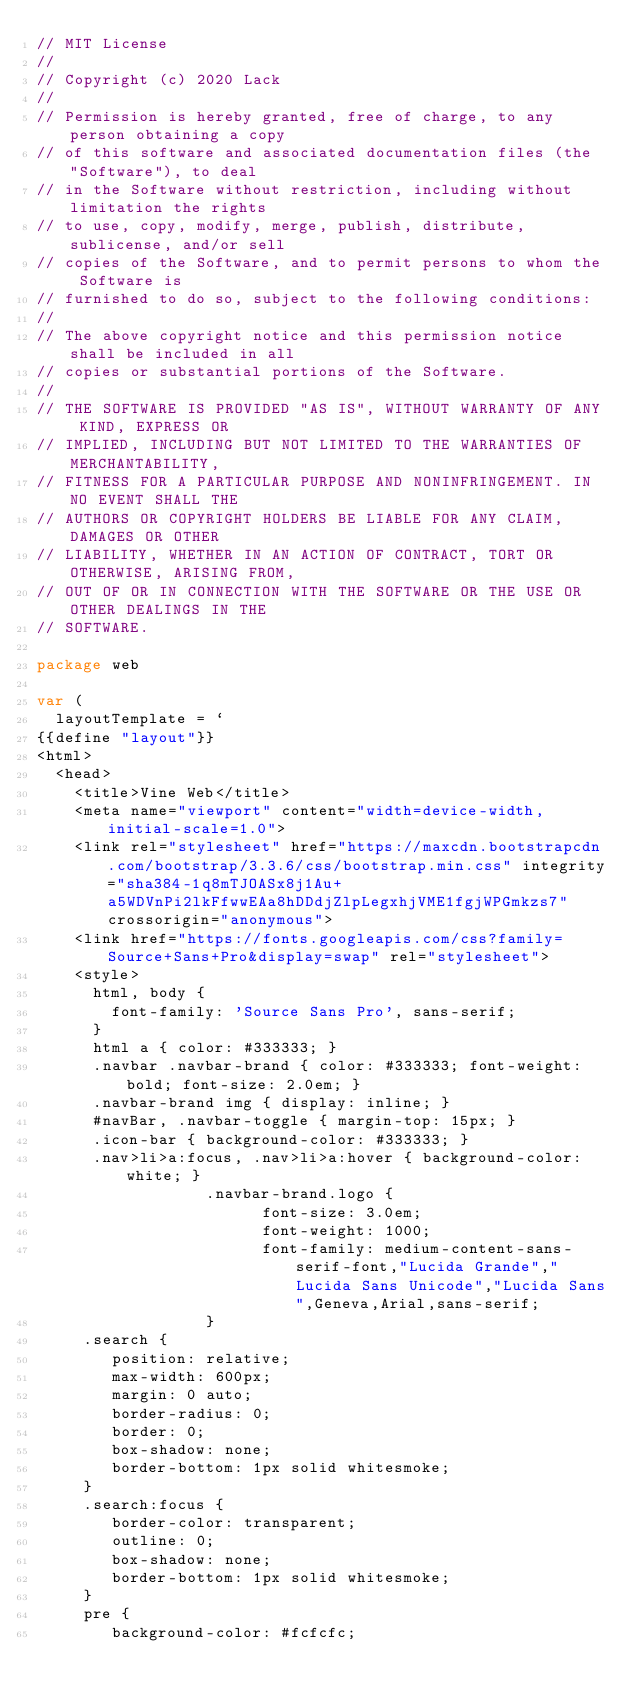<code> <loc_0><loc_0><loc_500><loc_500><_Go_>// MIT License
//
// Copyright (c) 2020 Lack
//
// Permission is hereby granted, free of charge, to any person obtaining a copy
// of this software and associated documentation files (the "Software"), to deal
// in the Software without restriction, including without limitation the rights
// to use, copy, modify, merge, publish, distribute, sublicense, and/or sell
// copies of the Software, and to permit persons to whom the Software is
// furnished to do so, subject to the following conditions:
//
// The above copyright notice and this permission notice shall be included in all
// copies or substantial portions of the Software.
//
// THE SOFTWARE IS PROVIDED "AS IS", WITHOUT WARRANTY OF ANY KIND, EXPRESS OR
// IMPLIED, INCLUDING BUT NOT LIMITED TO THE WARRANTIES OF MERCHANTABILITY,
// FITNESS FOR A PARTICULAR PURPOSE AND NONINFRINGEMENT. IN NO EVENT SHALL THE
// AUTHORS OR COPYRIGHT HOLDERS BE LIABLE FOR ANY CLAIM, DAMAGES OR OTHER
// LIABILITY, WHETHER IN AN ACTION OF CONTRACT, TORT OR OTHERWISE, ARISING FROM,
// OUT OF OR IN CONNECTION WITH THE SOFTWARE OR THE USE OR OTHER DEALINGS IN THE
// SOFTWARE.

package web

var (
	layoutTemplate = `
{{define "layout"}}
<html>
	<head>
		<title>Vine Web</title>
		<meta name="viewport" content="width=device-width, initial-scale=1.0">
		<link rel="stylesheet" href="https://maxcdn.bootstrapcdn.com/bootstrap/3.3.6/css/bootstrap.min.css" integrity="sha384-1q8mTJOASx8j1Au+a5WDVnPi2lkFfwwEAa8hDDdjZlpLegxhjVME1fgjWPGmkzs7" crossorigin="anonymous">
		<link href="https://fonts.googleapis.com/css?family=Source+Sans+Pro&display=swap" rel="stylesheet">
		<style>
		  html, body {
		    font-family: 'Source Sans Pro', sans-serif;
		  }
		  html a { color: #333333; }
		  .navbar .navbar-brand { color: #333333; font-weight: bold; font-size: 2.0em; }
		  .navbar-brand img { display: inline; }
		  #navBar, .navbar-toggle { margin-top: 15px; }
		  .icon-bar { background-color: #333333; }
		  .nav>li>a:focus, .nav>li>a:hover { background-color: white; }
                  .navbar-brand.logo {
                        font-size: 3.0em;
                        font-weight: 1000;
                        font-family: medium-content-sans-serif-font,"Lucida Grande","Lucida Sans Unicode","Lucida Sans",Geneva,Arial,sans-serif;
                  }
		 .search {
		    position: relative;
		    max-width: 600px;
		    margin: 0 auto;
		    border-radius: 0;
		    border: 0;
		    box-shadow: none;
		    border-bottom: 1px solid whitesmoke;
		 }
		 .search:focus {
		    border-color: transparent;
		    outline: 0;
		    box-shadow: none;
		    border-bottom: 1px solid whitesmoke;
	 	 }
		 pre {
		    background-color: #fcfcfc;</code> 